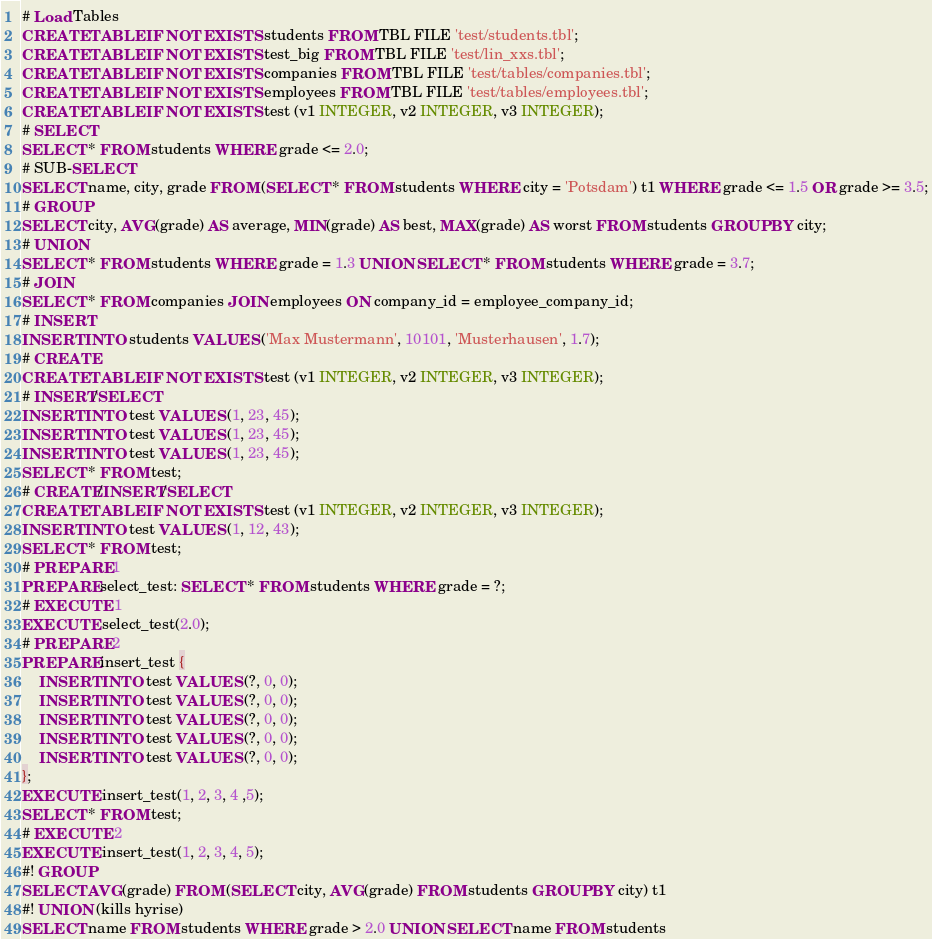Convert code to text. <code><loc_0><loc_0><loc_500><loc_500><_SQL_># Load Tables
CREATE TABLE IF NOT EXISTS students FROM TBL FILE 'test/students.tbl';
CREATE TABLE IF NOT EXISTS test_big FROM TBL FILE 'test/lin_xxs.tbl';
CREATE TABLE IF NOT EXISTS companies FROM TBL FILE 'test/tables/companies.tbl';
CREATE TABLE IF NOT EXISTS employees FROM TBL FILE 'test/tables/employees.tbl';
CREATE TABLE IF NOT EXISTS test (v1 INTEGER, v2 INTEGER, v3 INTEGER);
# SELECT
SELECT * FROM students WHERE grade <= 2.0;
# SUB-SELECT
SELECT name, city, grade FROM (SELECT * FROM students WHERE city = 'Potsdam') t1 WHERE grade <= 1.5 OR grade >= 3.5;
# GROUP
SELECT city, AVG(grade) AS average, MIN(grade) AS best, MAX(grade) AS worst FROM students GROUP BY city;
# UNION
SELECT * FROM students WHERE grade = 1.3 UNION SELECT * FROM students WHERE grade = 3.7;
# JOIN
SELECT * FROM companies JOIN employees ON company_id = employee_company_id;
# INSERT
INSERT INTO students VALUES ('Max Mustermann', 10101, 'Musterhausen', 1.7);
# CREATE
CREATE TABLE IF NOT EXISTS test (v1 INTEGER, v2 INTEGER, v3 INTEGER);
# INSERT/SELECT
INSERT INTO test VALUES (1, 23, 45);
INSERT INTO test VALUES (1, 23, 45);
INSERT INTO test VALUES (1, 23, 45);
SELECT * FROM test;
# CREATE/INSERT/SELECT
CREATE TABLE IF NOT EXISTS test (v1 INTEGER, v2 INTEGER, v3 INTEGER);
INSERT INTO test VALUES (1, 12, 43);
SELECT * FROM test;
# PREPARE 1
PREPARE select_test: SELECT * FROM students WHERE grade = ?;
# EXECUTE 1
EXECUTE select_test(2.0);
# PREPARE 2
PREPARE insert_test {
	INSERT INTO test VALUES (?, 0, 0);
	INSERT INTO test VALUES (?, 0, 0);
	INSERT INTO test VALUES (?, 0, 0);
	INSERT INTO test VALUES (?, 0, 0);
	INSERT INTO test VALUES (?, 0, 0);
};
EXECUTE insert_test(1, 2, 3, 4 ,5);
SELECT * FROM test;
# EXECUTE 2
EXECUTE insert_test(1, 2, 3, 4, 5);
#! GROUP
SELECT AVG(grade) FROM (SELECT city, AVG(grade) FROM students GROUP BY city) t1
#! UNION (kills hyrise)
SELECT name FROM students WHERE grade > 2.0 UNION SELECT name FROM students</code> 